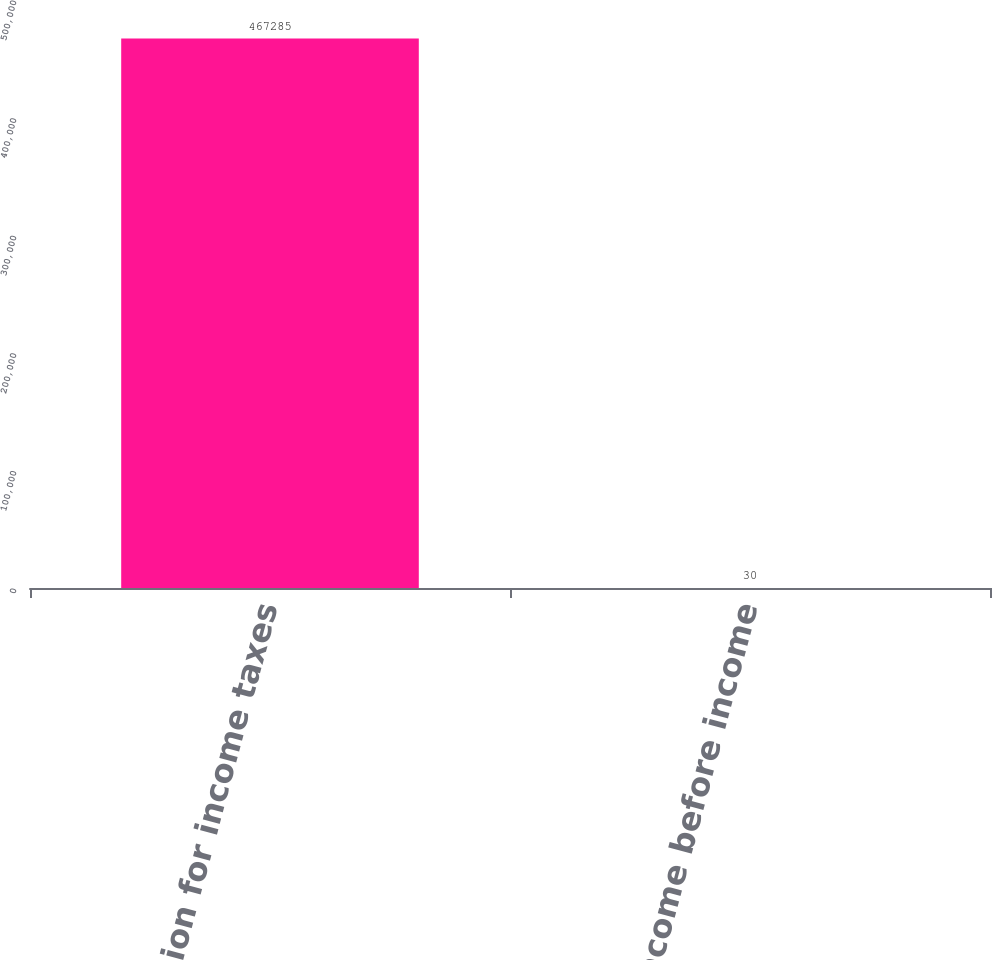<chart> <loc_0><loc_0><loc_500><loc_500><bar_chart><fcel>Provision for income taxes<fcel>As a of income before income<nl><fcel>467285<fcel>30<nl></chart> 